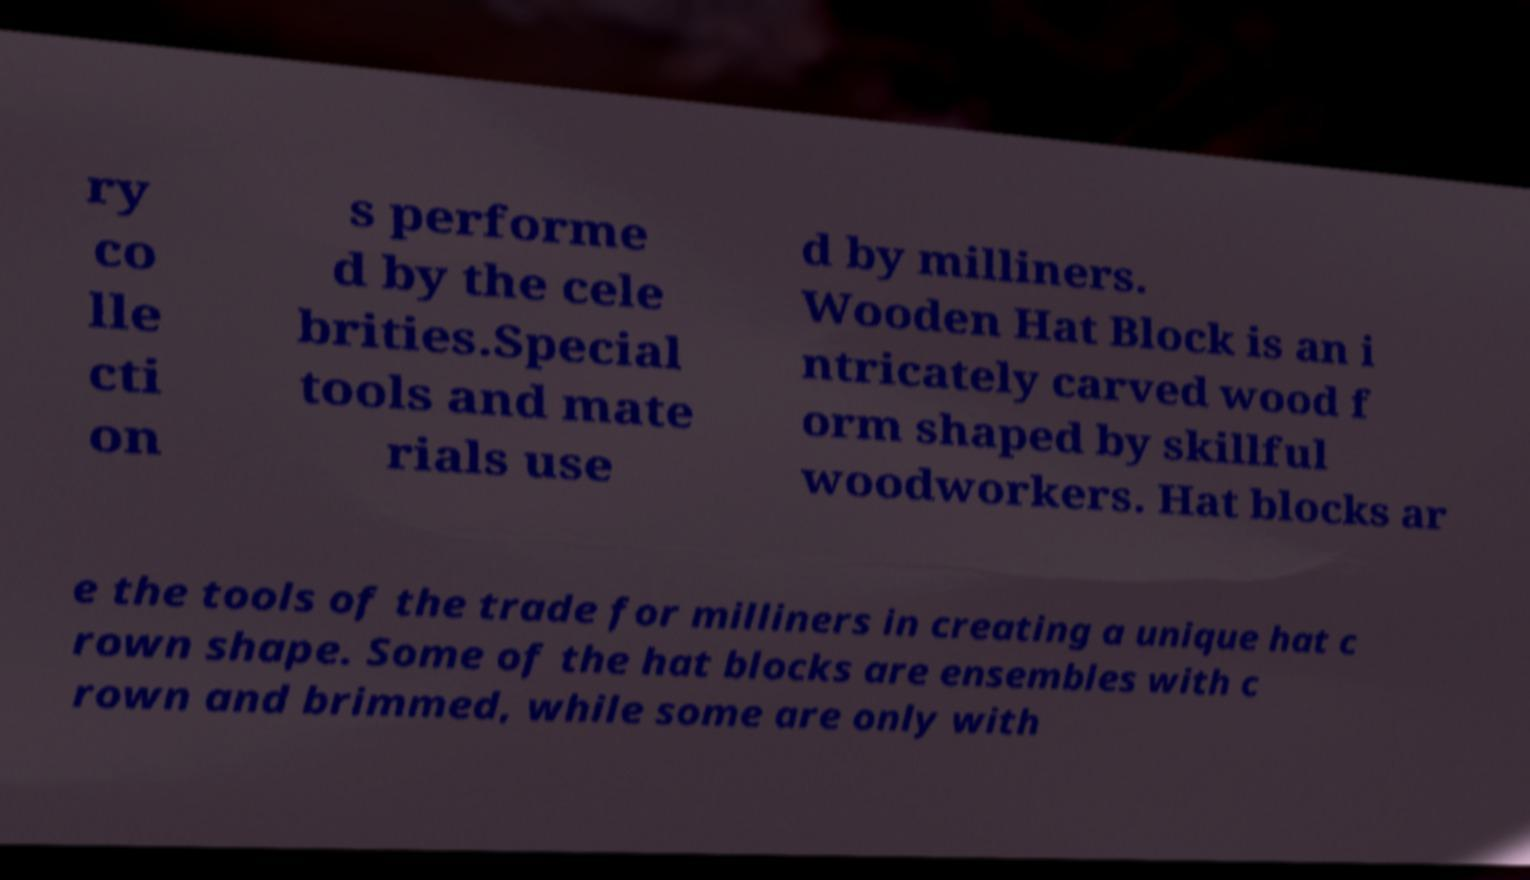Can you accurately transcribe the text from the provided image for me? ry co lle cti on s performe d by the cele brities.Special tools and mate rials use d by milliners. Wooden Hat Block is an i ntricately carved wood f orm shaped by skillful woodworkers. Hat blocks ar e the tools of the trade for milliners in creating a unique hat c rown shape. Some of the hat blocks are ensembles with c rown and brimmed, while some are only with 